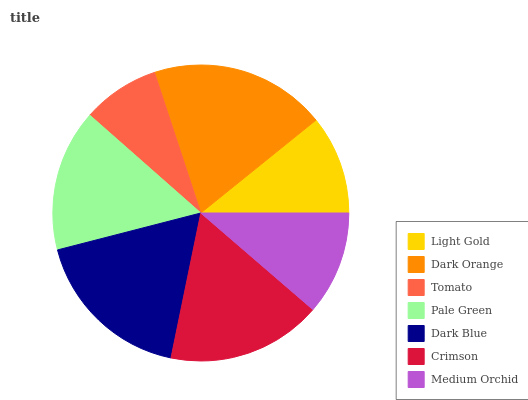Is Tomato the minimum?
Answer yes or no. Yes. Is Dark Orange the maximum?
Answer yes or no. Yes. Is Dark Orange the minimum?
Answer yes or no. No. Is Tomato the maximum?
Answer yes or no. No. Is Dark Orange greater than Tomato?
Answer yes or no. Yes. Is Tomato less than Dark Orange?
Answer yes or no. Yes. Is Tomato greater than Dark Orange?
Answer yes or no. No. Is Dark Orange less than Tomato?
Answer yes or no. No. Is Pale Green the high median?
Answer yes or no. Yes. Is Pale Green the low median?
Answer yes or no. Yes. Is Tomato the high median?
Answer yes or no. No. Is Dark Orange the low median?
Answer yes or no. No. 